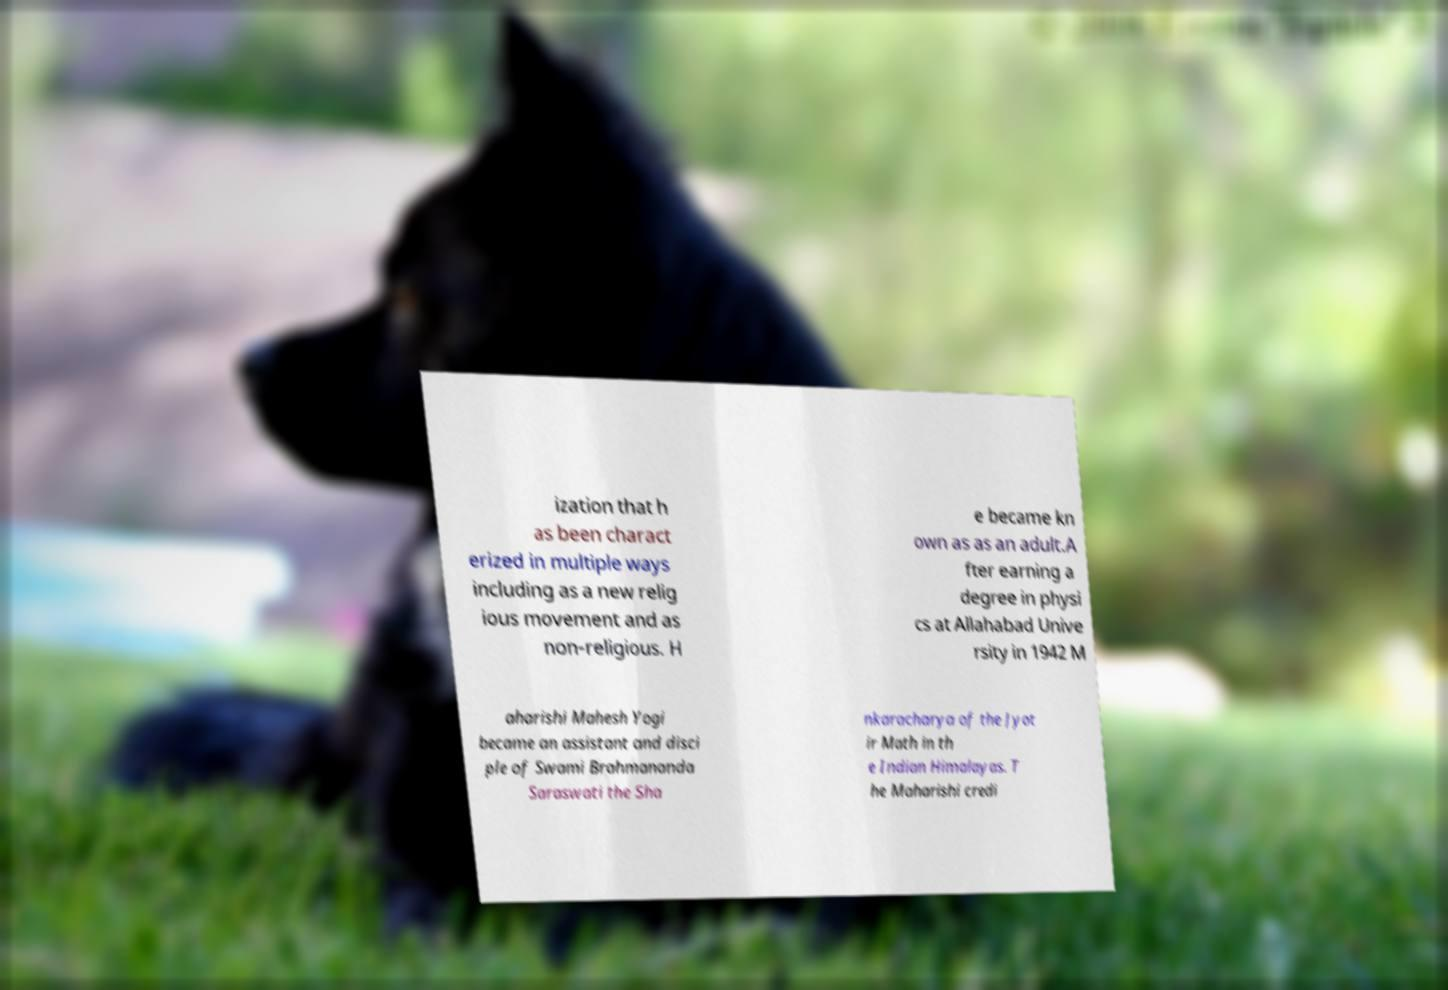Can you read and provide the text displayed in the image?This photo seems to have some interesting text. Can you extract and type it out for me? ization that h as been charact erized in multiple ways including as a new relig ious movement and as non-religious. H e became kn own as as an adult.A fter earning a degree in physi cs at Allahabad Unive rsity in 1942 M aharishi Mahesh Yogi became an assistant and disci ple of Swami Brahmananda Saraswati the Sha nkaracharya of the Jyot ir Math in th e Indian Himalayas. T he Maharishi credi 